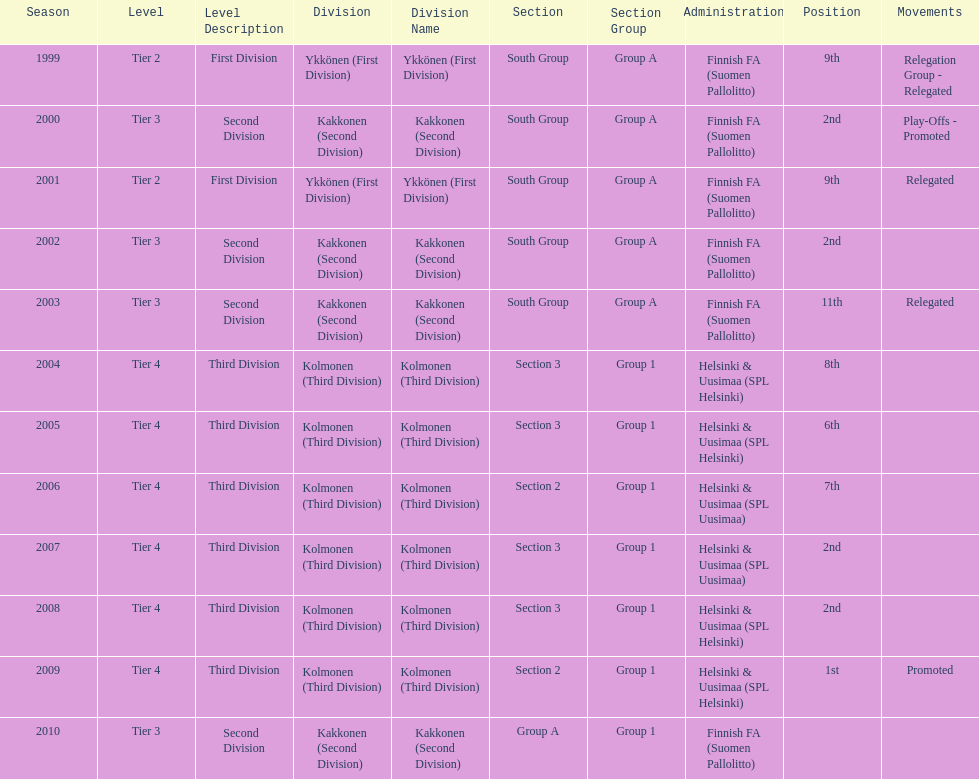How many times has this team been relegated? 3. 